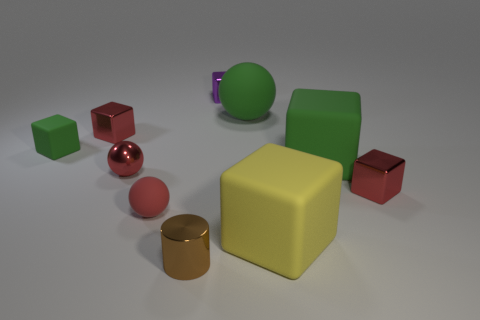Subtract all red balls. How many were subtracted if there are1red balls left? 1 Subtract 3 blocks. How many blocks are left? 3 Subtract all purple cubes. How many cubes are left? 5 Subtract all yellow blocks. How many blocks are left? 5 Subtract all gray blocks. Subtract all cyan spheres. How many blocks are left? 6 Subtract all blocks. How many objects are left? 4 Subtract 0 gray cylinders. How many objects are left? 10 Subtract all tiny red matte things. Subtract all tiny brown metallic things. How many objects are left? 8 Add 5 brown cylinders. How many brown cylinders are left? 6 Add 5 small blue metallic things. How many small blue metallic things exist? 5 